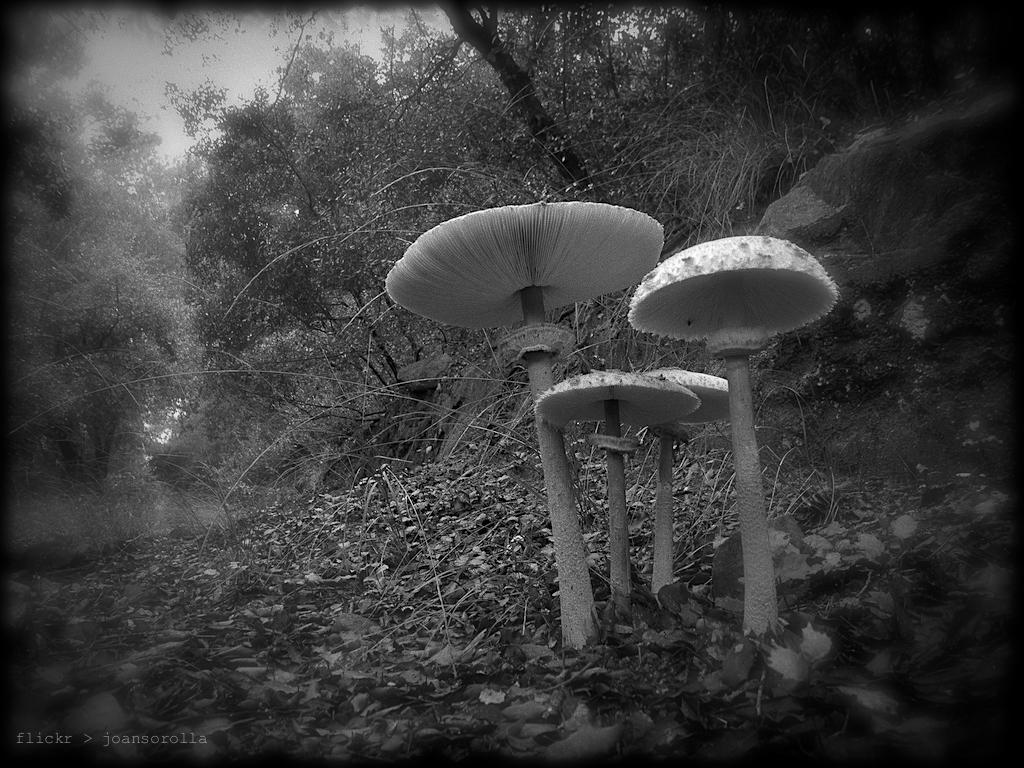What is the color scheme of the image? The image is black and white. What type of natural elements can be seen in the image? There are trees and mushrooms in the image. Is there any text present in the image? Yes, there is text at the bottom of the image. What type of work does the fireman do in the image? There is no fireman present in the image. Can you compare the size of the mushrooms to the trees in the image? The provided facts do not include information about the size of the mushrooms or trees, so it is not possible to make a comparison. 